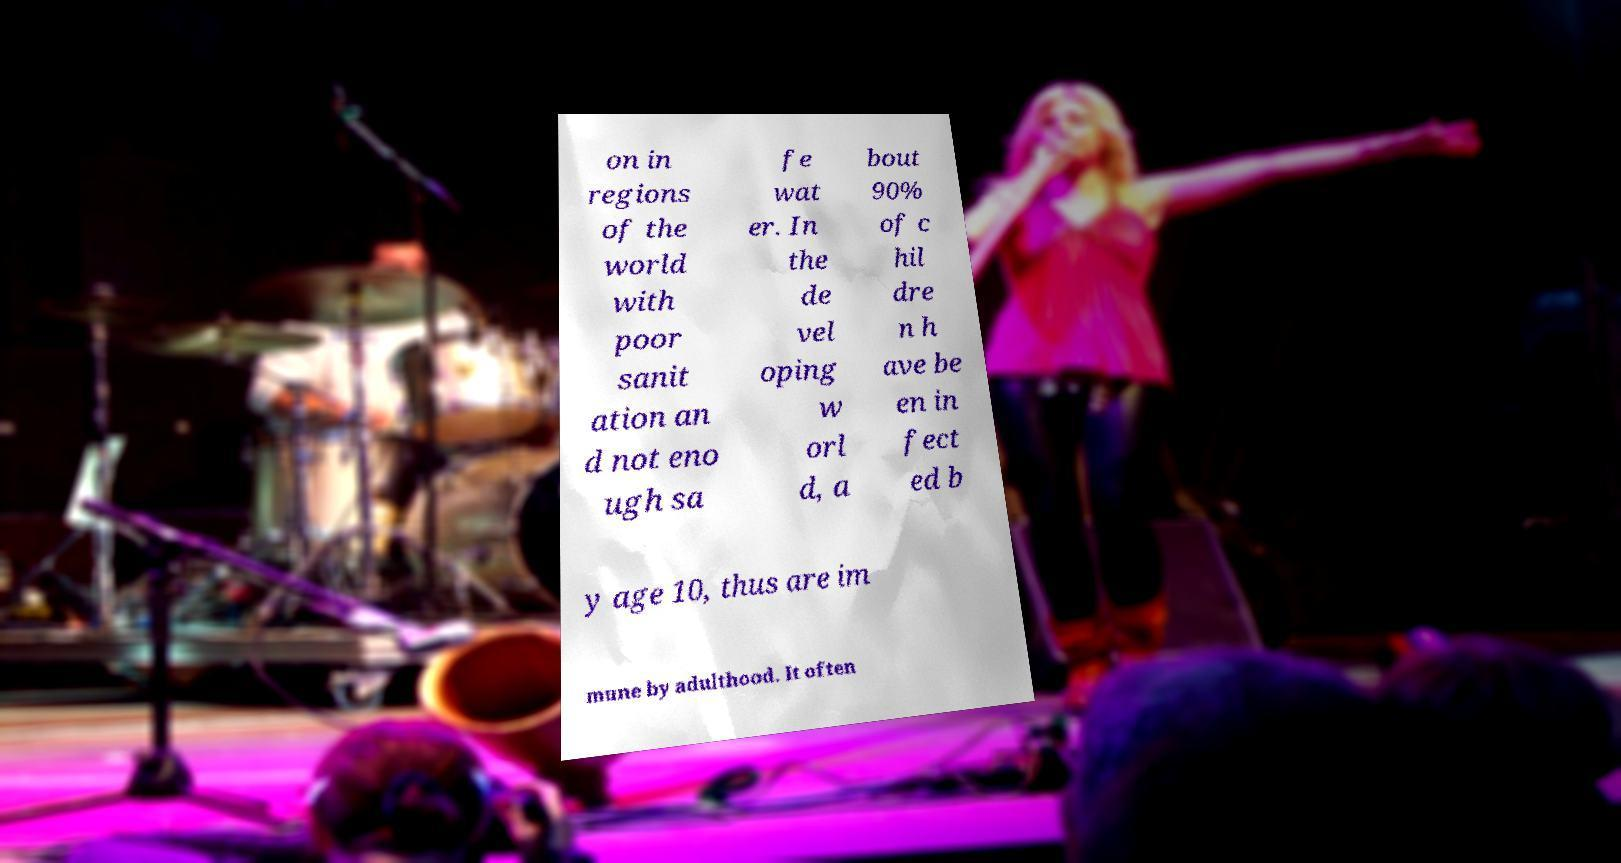What messages or text are displayed in this image? I need them in a readable, typed format. on in regions of the world with poor sanit ation an d not eno ugh sa fe wat er. In the de vel oping w orl d, a bout 90% of c hil dre n h ave be en in fect ed b y age 10, thus are im mune by adulthood. It often 